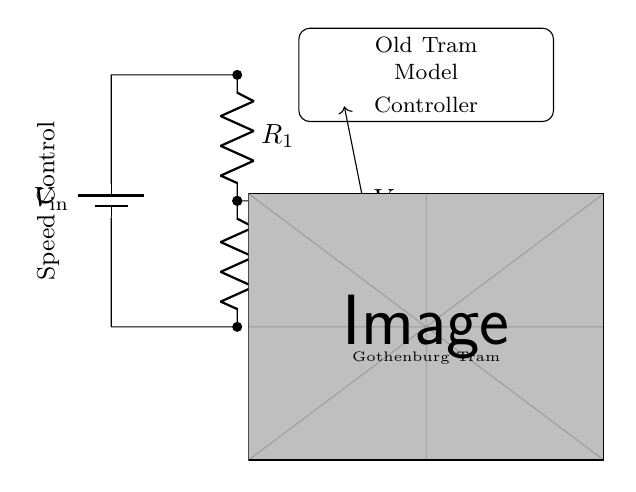What is the input voltage in the circuit? The input voltage, denoted as V_in, is represented by the battery symbol at the left side of the circuit. The exact voltage value might not be specified in the visual, but it signifies the source voltage supplied to the voltage divider.
Answer: V_in What components are used in this voltage divider? The circuit consists of a battery (V_in) and two resistors (R_1 and R_2). They are connected in series, forming the voltage divider, which splits the voltage between them.
Answer: Battery, R_1, R_2 What is the output voltage taken from? The output voltage, V_out, is taken from the junction between the two resistors, R_1 and R_2. This is where the voltage is divided and can be used to control the speed of the tram model.
Answer: Junction of R_1 and R_2 How does varying R_1 and R_2 affect V_out? Changing the values of R_1 and R_2 alters the voltage division based on the formula V_out = V_in * (R_2 / (R_1 + R_2)). This means increasing R_2 will increase V_out, while increasing R_1 will decrease it.
Answer: Affects V_out What is the purpose of this circuit in relation to the tram model? The purpose of this voltage divider is to control the speed of the old electric tram model by providing a varying output voltage that adjusts the tram's motor speed, allowing for smoother operation.
Answer: Speed control If R_1 is 10 ohms and R_2 is 10 ohms, what is V_out if V_in is 12 volts? Using the voltage divider formula V_out = V_in * (R_2 / (R_1 + R_2)), we substitute 12 for V_in and both R_1 and R_2 as 10 ohms: V_out = 12 * (10 / (10 + 10)) = 6 volts. Thus, the output voltage would be 6 volts when the input is 12 volts.
Answer: 6 volts 